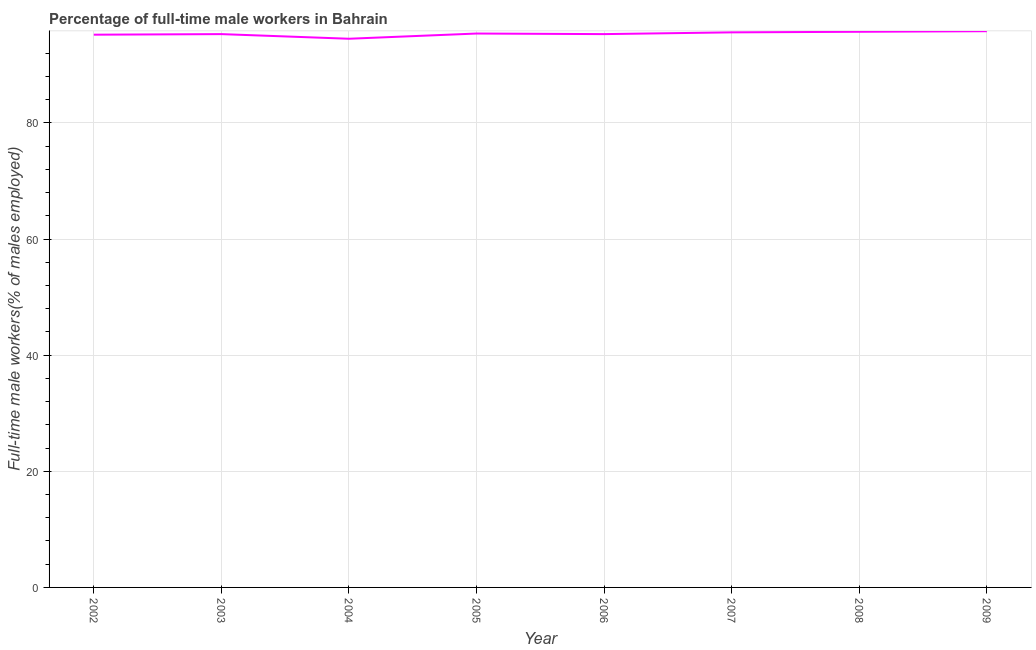What is the percentage of full-time male workers in 2003?
Keep it short and to the point. 95.3. Across all years, what is the maximum percentage of full-time male workers?
Your answer should be very brief. 95.8. Across all years, what is the minimum percentage of full-time male workers?
Offer a terse response. 94.5. What is the sum of the percentage of full-time male workers?
Your answer should be very brief. 762.8. What is the difference between the percentage of full-time male workers in 2004 and 2006?
Make the answer very short. -0.8. What is the average percentage of full-time male workers per year?
Your answer should be compact. 95.35. What is the median percentage of full-time male workers?
Your answer should be very brief. 95.35. Do a majority of the years between 2009 and 2005 (inclusive) have percentage of full-time male workers greater than 52 %?
Keep it short and to the point. Yes. What is the ratio of the percentage of full-time male workers in 2003 to that in 2007?
Keep it short and to the point. 1. Is the percentage of full-time male workers in 2002 less than that in 2008?
Your response must be concise. Yes. What is the difference between the highest and the second highest percentage of full-time male workers?
Make the answer very short. 0.1. What is the difference between the highest and the lowest percentage of full-time male workers?
Make the answer very short. 1.3. In how many years, is the percentage of full-time male workers greater than the average percentage of full-time male workers taken over all years?
Make the answer very short. 4. How many lines are there?
Your answer should be compact. 1. How many years are there in the graph?
Offer a terse response. 8. Are the values on the major ticks of Y-axis written in scientific E-notation?
Make the answer very short. No. Does the graph contain any zero values?
Your response must be concise. No. What is the title of the graph?
Your answer should be compact. Percentage of full-time male workers in Bahrain. What is the label or title of the X-axis?
Ensure brevity in your answer.  Year. What is the label or title of the Y-axis?
Provide a succinct answer. Full-time male workers(% of males employed). What is the Full-time male workers(% of males employed) in 2002?
Provide a succinct answer. 95.2. What is the Full-time male workers(% of males employed) of 2003?
Your answer should be compact. 95.3. What is the Full-time male workers(% of males employed) of 2004?
Provide a short and direct response. 94.5. What is the Full-time male workers(% of males employed) in 2005?
Your response must be concise. 95.4. What is the Full-time male workers(% of males employed) of 2006?
Offer a very short reply. 95.3. What is the Full-time male workers(% of males employed) in 2007?
Your answer should be compact. 95.6. What is the Full-time male workers(% of males employed) of 2008?
Your response must be concise. 95.7. What is the Full-time male workers(% of males employed) of 2009?
Ensure brevity in your answer.  95.8. What is the difference between the Full-time male workers(% of males employed) in 2002 and 2003?
Your answer should be very brief. -0.1. What is the difference between the Full-time male workers(% of males employed) in 2002 and 2005?
Offer a terse response. -0.2. What is the difference between the Full-time male workers(% of males employed) in 2002 and 2006?
Provide a short and direct response. -0.1. What is the difference between the Full-time male workers(% of males employed) in 2002 and 2008?
Make the answer very short. -0.5. What is the difference between the Full-time male workers(% of males employed) in 2002 and 2009?
Ensure brevity in your answer.  -0.6. What is the difference between the Full-time male workers(% of males employed) in 2003 and 2006?
Ensure brevity in your answer.  0. What is the difference between the Full-time male workers(% of males employed) in 2003 and 2008?
Offer a very short reply. -0.4. What is the difference between the Full-time male workers(% of males employed) in 2003 and 2009?
Your answer should be very brief. -0.5. What is the difference between the Full-time male workers(% of males employed) in 2004 and 2005?
Keep it short and to the point. -0.9. What is the difference between the Full-time male workers(% of males employed) in 2004 and 2006?
Keep it short and to the point. -0.8. What is the difference between the Full-time male workers(% of males employed) in 2004 and 2008?
Your response must be concise. -1.2. What is the difference between the Full-time male workers(% of males employed) in 2004 and 2009?
Provide a succinct answer. -1.3. What is the difference between the Full-time male workers(% of males employed) in 2005 and 2007?
Your answer should be compact. -0.2. What is the difference between the Full-time male workers(% of males employed) in 2005 and 2009?
Ensure brevity in your answer.  -0.4. What is the difference between the Full-time male workers(% of males employed) in 2006 and 2008?
Offer a terse response. -0.4. What is the difference between the Full-time male workers(% of males employed) in 2007 and 2008?
Make the answer very short. -0.1. What is the difference between the Full-time male workers(% of males employed) in 2007 and 2009?
Keep it short and to the point. -0.2. What is the difference between the Full-time male workers(% of males employed) in 2008 and 2009?
Keep it short and to the point. -0.1. What is the ratio of the Full-time male workers(% of males employed) in 2002 to that in 2003?
Offer a very short reply. 1. What is the ratio of the Full-time male workers(% of males employed) in 2002 to that in 2005?
Offer a very short reply. 1. What is the ratio of the Full-time male workers(% of males employed) in 2002 to that in 2007?
Provide a succinct answer. 1. What is the ratio of the Full-time male workers(% of males employed) in 2002 to that in 2008?
Your answer should be very brief. 0.99. What is the ratio of the Full-time male workers(% of males employed) in 2003 to that in 2004?
Offer a very short reply. 1.01. What is the ratio of the Full-time male workers(% of males employed) in 2003 to that in 2005?
Your answer should be very brief. 1. What is the ratio of the Full-time male workers(% of males employed) in 2003 to that in 2006?
Your response must be concise. 1. What is the ratio of the Full-time male workers(% of males employed) in 2004 to that in 2006?
Give a very brief answer. 0.99. What is the ratio of the Full-time male workers(% of males employed) in 2004 to that in 2008?
Offer a terse response. 0.99. What is the ratio of the Full-time male workers(% of males employed) in 2005 to that in 2006?
Provide a succinct answer. 1. What is the ratio of the Full-time male workers(% of males employed) in 2005 to that in 2007?
Provide a short and direct response. 1. What is the ratio of the Full-time male workers(% of males employed) in 2005 to that in 2009?
Your answer should be very brief. 1. What is the ratio of the Full-time male workers(% of males employed) in 2006 to that in 2008?
Ensure brevity in your answer.  1. What is the ratio of the Full-time male workers(% of males employed) in 2007 to that in 2008?
Provide a succinct answer. 1. 